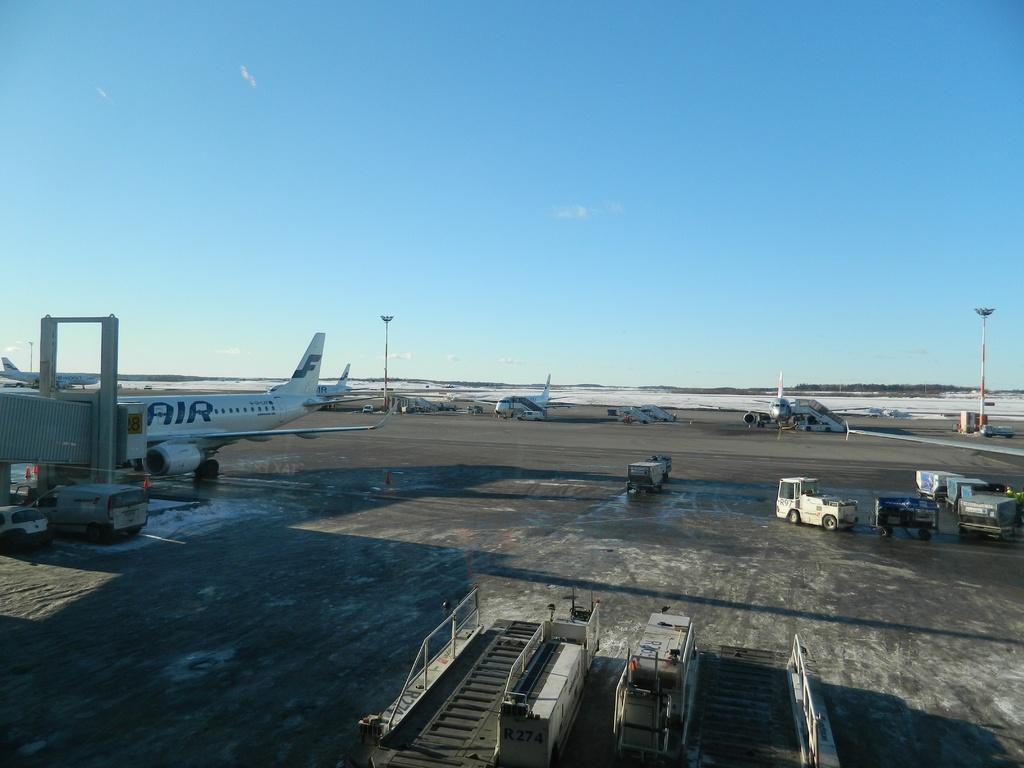Please provide a concise description of this image. In this image I can see few vehicles and I can also see few aircraft, light poles. In the background I can see few trees and the sky is in blue color. 